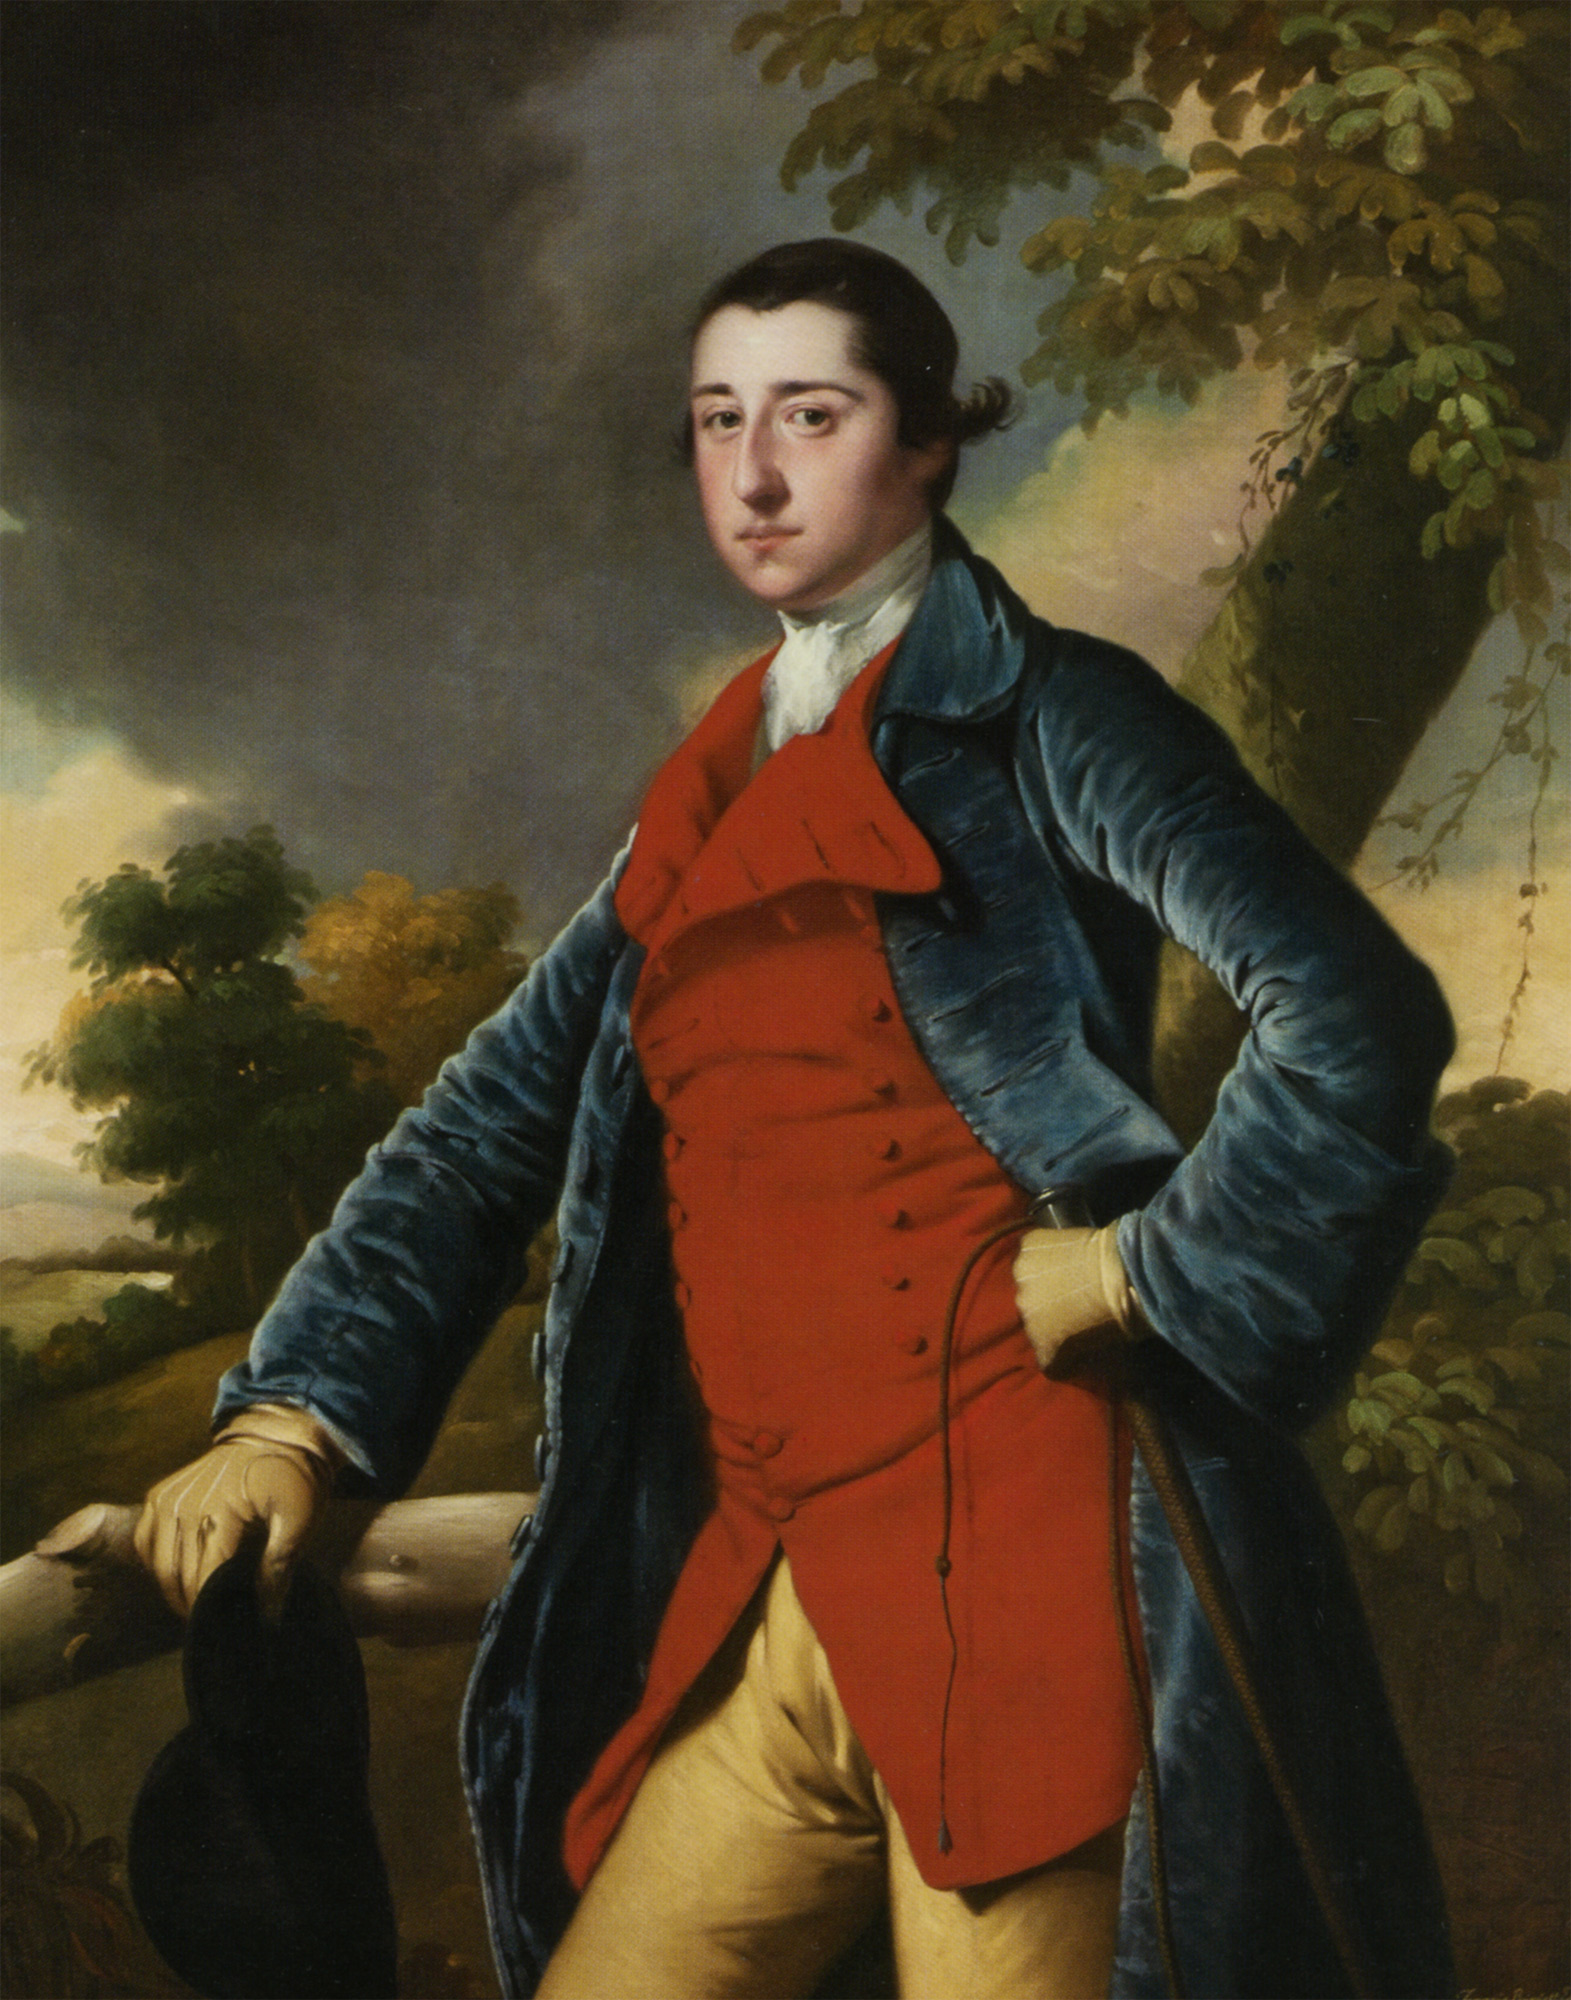Imagine the conversation this man might be having while posed in this environment. One might imagine the man engaging in a thoughtful conversation about art, philosophy, or politics with a companion or an artist. He could be discussing the importance of maintaining one's stature in society, the beauty of the natural landscape surrounding him, or the latest intellectual currents of the Enlightenment period. The serene and composed expression suggests a man of contemplation and refinement. What key topics would be relevant to an 18th-century socialite in such a setting? Key topics for an 18th-century socialite would likely include discussions on recent advancements in science and reasoning from the Enlightenment, the nuances of political power and its influence, artistic trends and patronage of the arts, and social etiquette and reputation. The spread of new political ideas, such as those concerning liberty and democracy, would also be of great interest, alongside the latest literature and philosophical debates shaping society. 